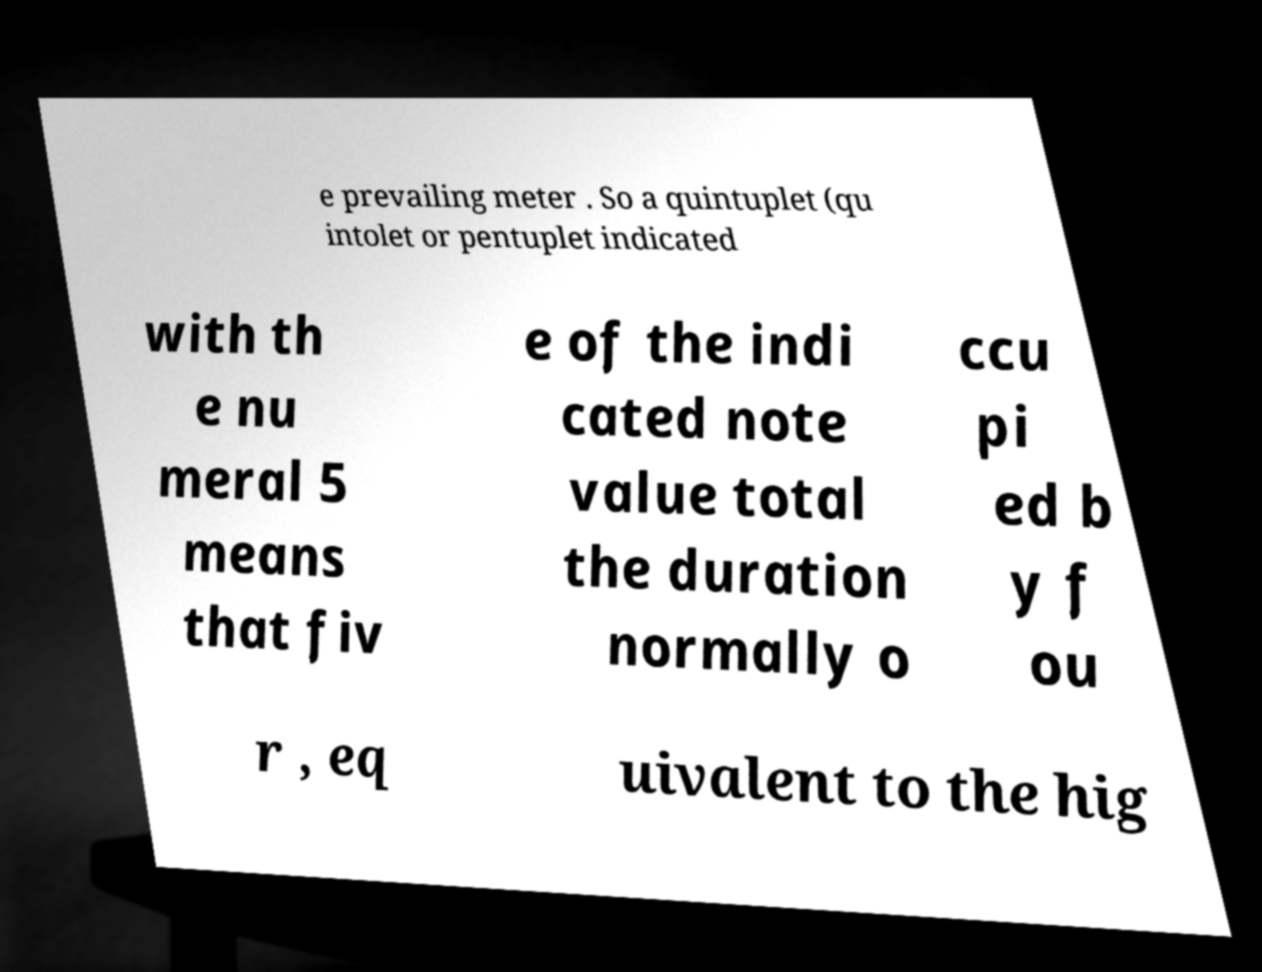Please read and relay the text visible in this image. What does it say? e prevailing meter . So a quintuplet (qu intolet or pentuplet indicated with th e nu meral 5 means that fiv e of the indi cated note value total the duration normally o ccu pi ed b y f ou r , eq uivalent to the hig 